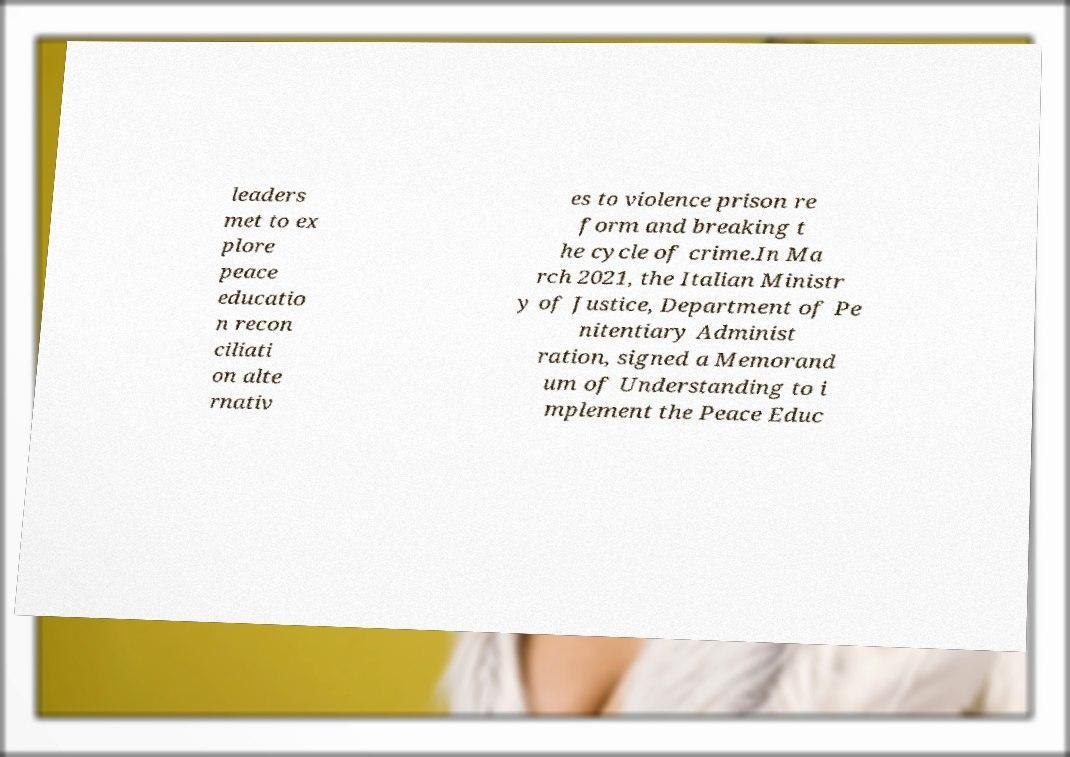What messages or text are displayed in this image? I need them in a readable, typed format. leaders met to ex plore peace educatio n recon ciliati on alte rnativ es to violence prison re form and breaking t he cycle of crime.In Ma rch 2021, the Italian Ministr y of Justice, Department of Pe nitentiary Administ ration, signed a Memorand um of Understanding to i mplement the Peace Educ 